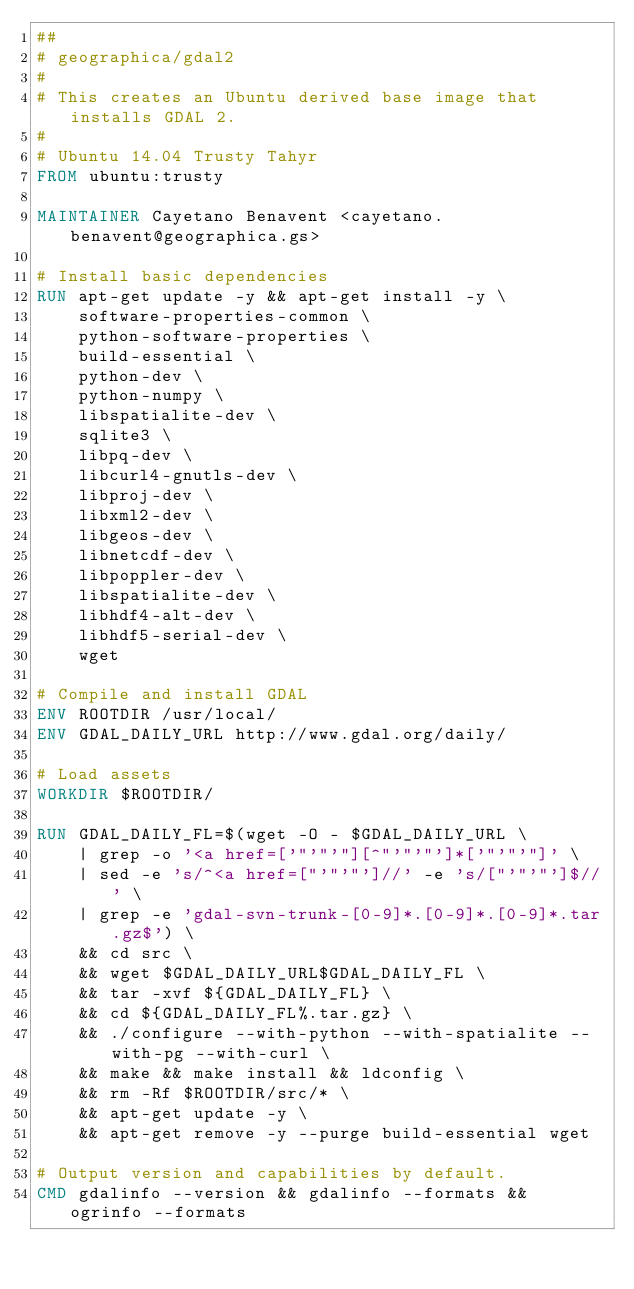Convert code to text. <code><loc_0><loc_0><loc_500><loc_500><_Dockerfile_>##
# geographica/gdal2
#
# This creates an Ubuntu derived base image that installs GDAL 2.
#
# Ubuntu 14.04 Trusty Tahyr
FROM ubuntu:trusty

MAINTAINER Cayetano Benavent <cayetano.benavent@geographica.gs>

# Install basic dependencies
RUN apt-get update -y && apt-get install -y \
    software-properties-common \
    python-software-properties \
    build-essential \
    python-dev \
    python-numpy \
    libspatialite-dev \
    sqlite3 \
    libpq-dev \
    libcurl4-gnutls-dev \
    libproj-dev \
    libxml2-dev \
    libgeos-dev \
    libnetcdf-dev \
    libpoppler-dev \
    libspatialite-dev \
    libhdf4-alt-dev \
    libhdf5-serial-dev \
    wget

# Compile and install GDAL
ENV ROOTDIR /usr/local/
ENV GDAL_DAILY_URL http://www.gdal.org/daily/

# Load assets
WORKDIR $ROOTDIR/

RUN GDAL_DAILY_FL=$(wget -O - $GDAL_DAILY_URL \
    | grep -o '<a href=['"'"'"][^"'"'"']*['"'"'"]' \
    | sed -e 's/^<a href=["'"'"']//' -e 's/["'"'"']$//' \
    | grep -e 'gdal-svn-trunk-[0-9]*.[0-9]*.[0-9]*.tar.gz$') \
    && cd src \
    && wget $GDAL_DAILY_URL$GDAL_DAILY_FL \
    && tar -xvf ${GDAL_DAILY_FL} \
    && cd ${GDAL_DAILY_FL%.tar.gz} \
    && ./configure --with-python --with-spatialite --with-pg --with-curl \
    && make && make install && ldconfig \
    && rm -Rf $ROOTDIR/src/* \
    && apt-get update -y \
    && apt-get remove -y --purge build-essential wget

# Output version and capabilities by default.
CMD gdalinfo --version && gdalinfo --formats && ogrinfo --formats
</code> 